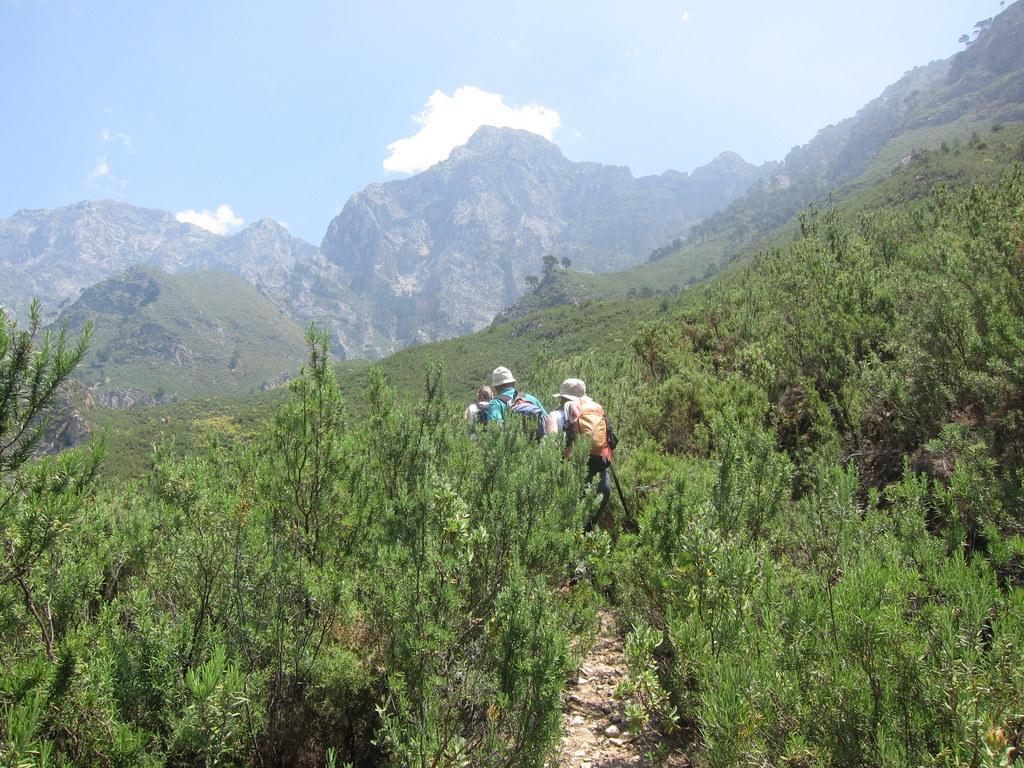What type of natural formation can be seen in the image? There are mountains in the image. What type of vegetation is present in the image? There are trees with branches and leaves in the image. How many people are visible in the image? There are three people standing in the image. What is visible at the top of the image? The sky is visible at the top of the image. What can be seen in the sky? There are clouds in the sky. What type of wine is being served by the servant in the image? There is no servant or wine present in the image. What type of woodworking tools does the carpenter have in the image? There is no carpenter or woodworking tools present in the image. 